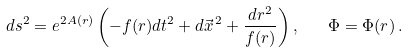<formula> <loc_0><loc_0><loc_500><loc_500>\ d s ^ { 2 } = e ^ { 2 A ( r ) } \left ( - f ( r ) d t ^ { 2 } + d \vec { x } ^ { \, 2 } + \frac { d r ^ { 2 } } { f ( r ) } \right ) , \quad \Phi = \Phi ( r ) \, .</formula> 